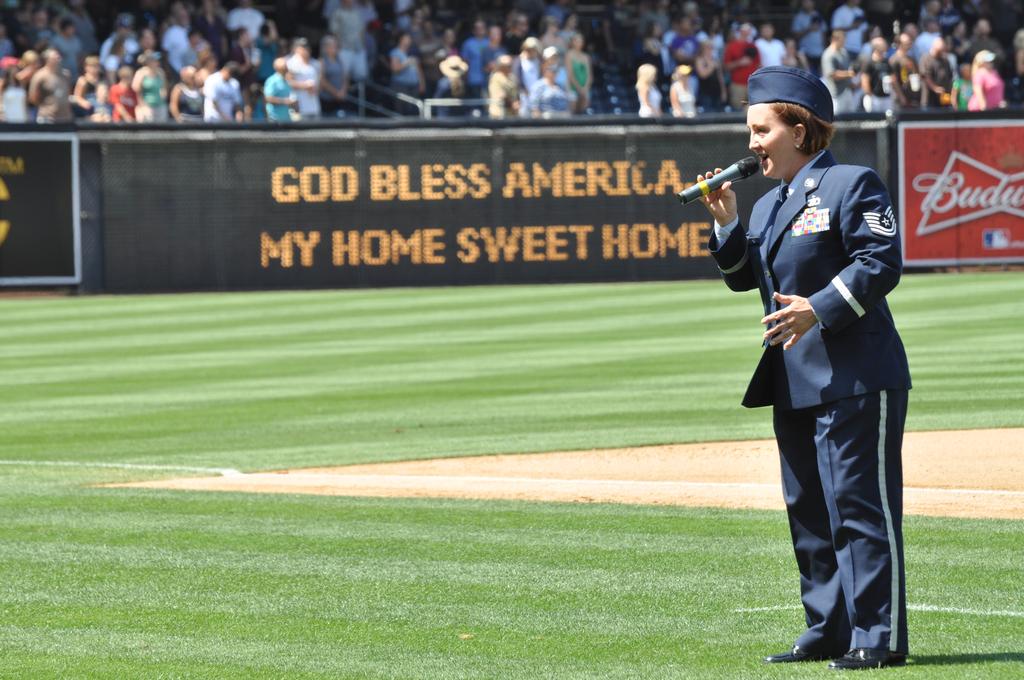What song is this women singing?
Give a very brief answer. God bless america. Who is god blessing?
Your answer should be very brief. America. 